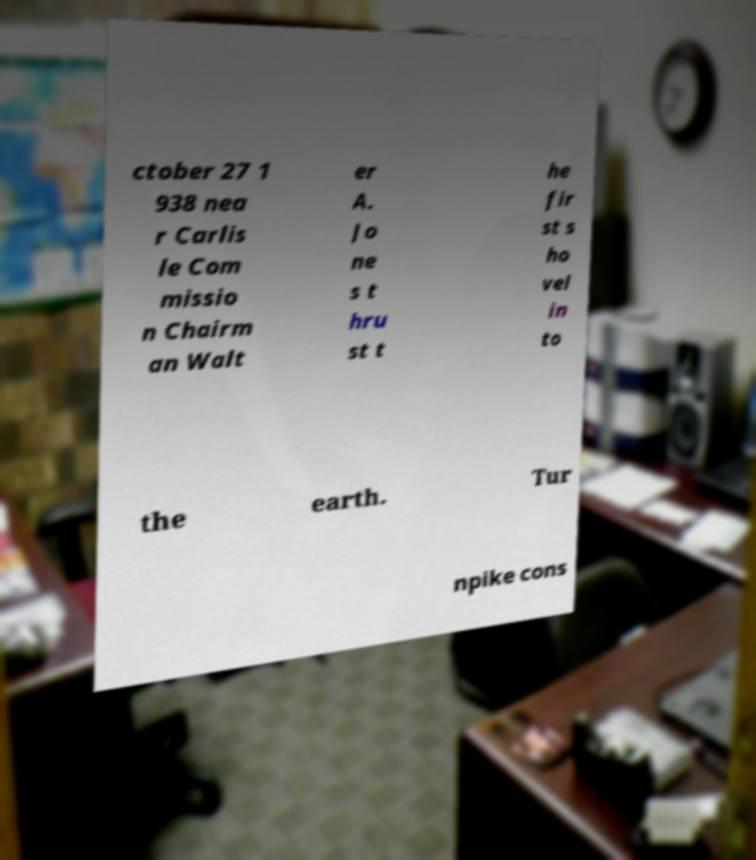Can you accurately transcribe the text from the provided image for me? ctober 27 1 938 nea r Carlis le Com missio n Chairm an Walt er A. Jo ne s t hru st t he fir st s ho vel in to the earth. Tur npike cons 